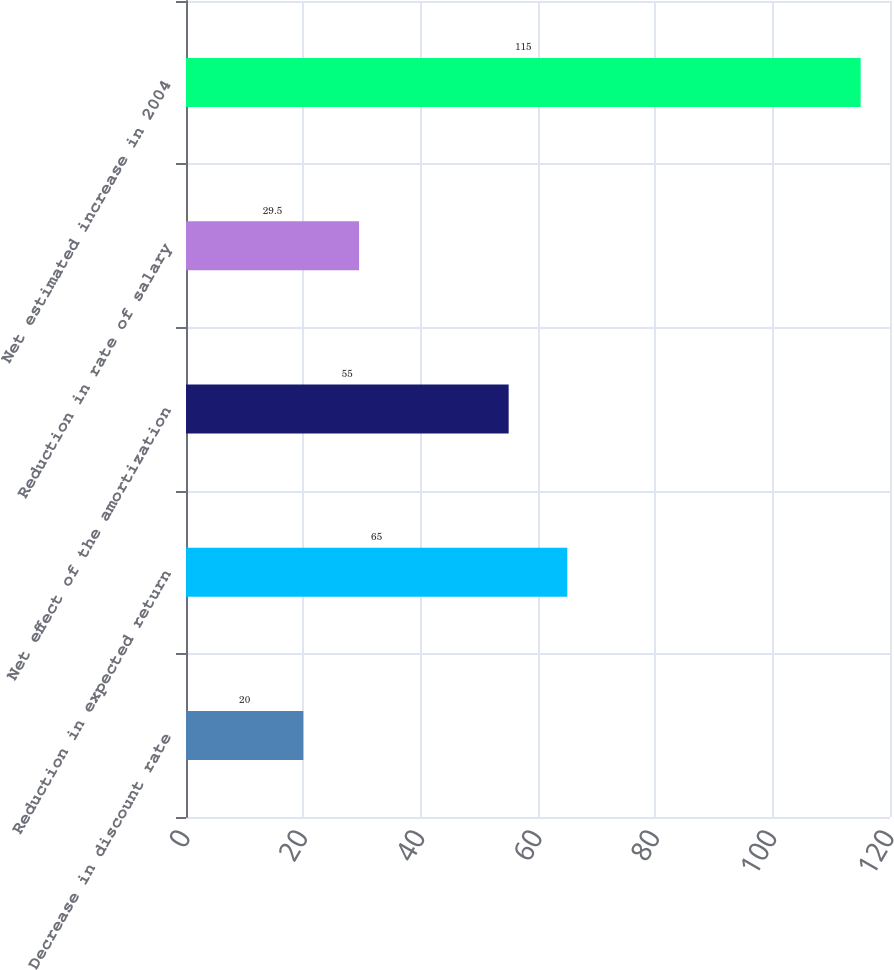Convert chart. <chart><loc_0><loc_0><loc_500><loc_500><bar_chart><fcel>Decrease in discount rate<fcel>Reduction in expected return<fcel>Net effect of the amortization<fcel>Reduction in rate of salary<fcel>Net estimated increase in 2004<nl><fcel>20<fcel>65<fcel>55<fcel>29.5<fcel>115<nl></chart> 